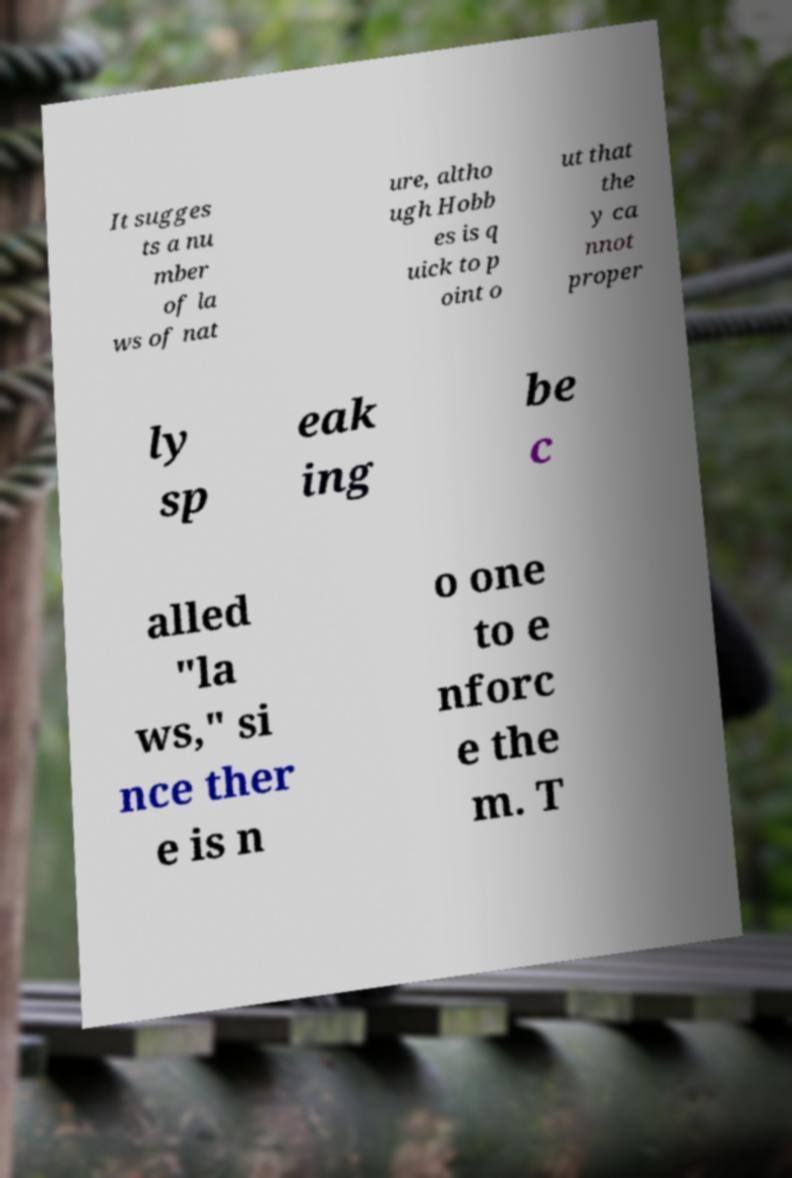Could you extract and type out the text from this image? It sugges ts a nu mber of la ws of nat ure, altho ugh Hobb es is q uick to p oint o ut that the y ca nnot proper ly sp eak ing be c alled "la ws," si nce ther e is n o one to e nforc e the m. T 